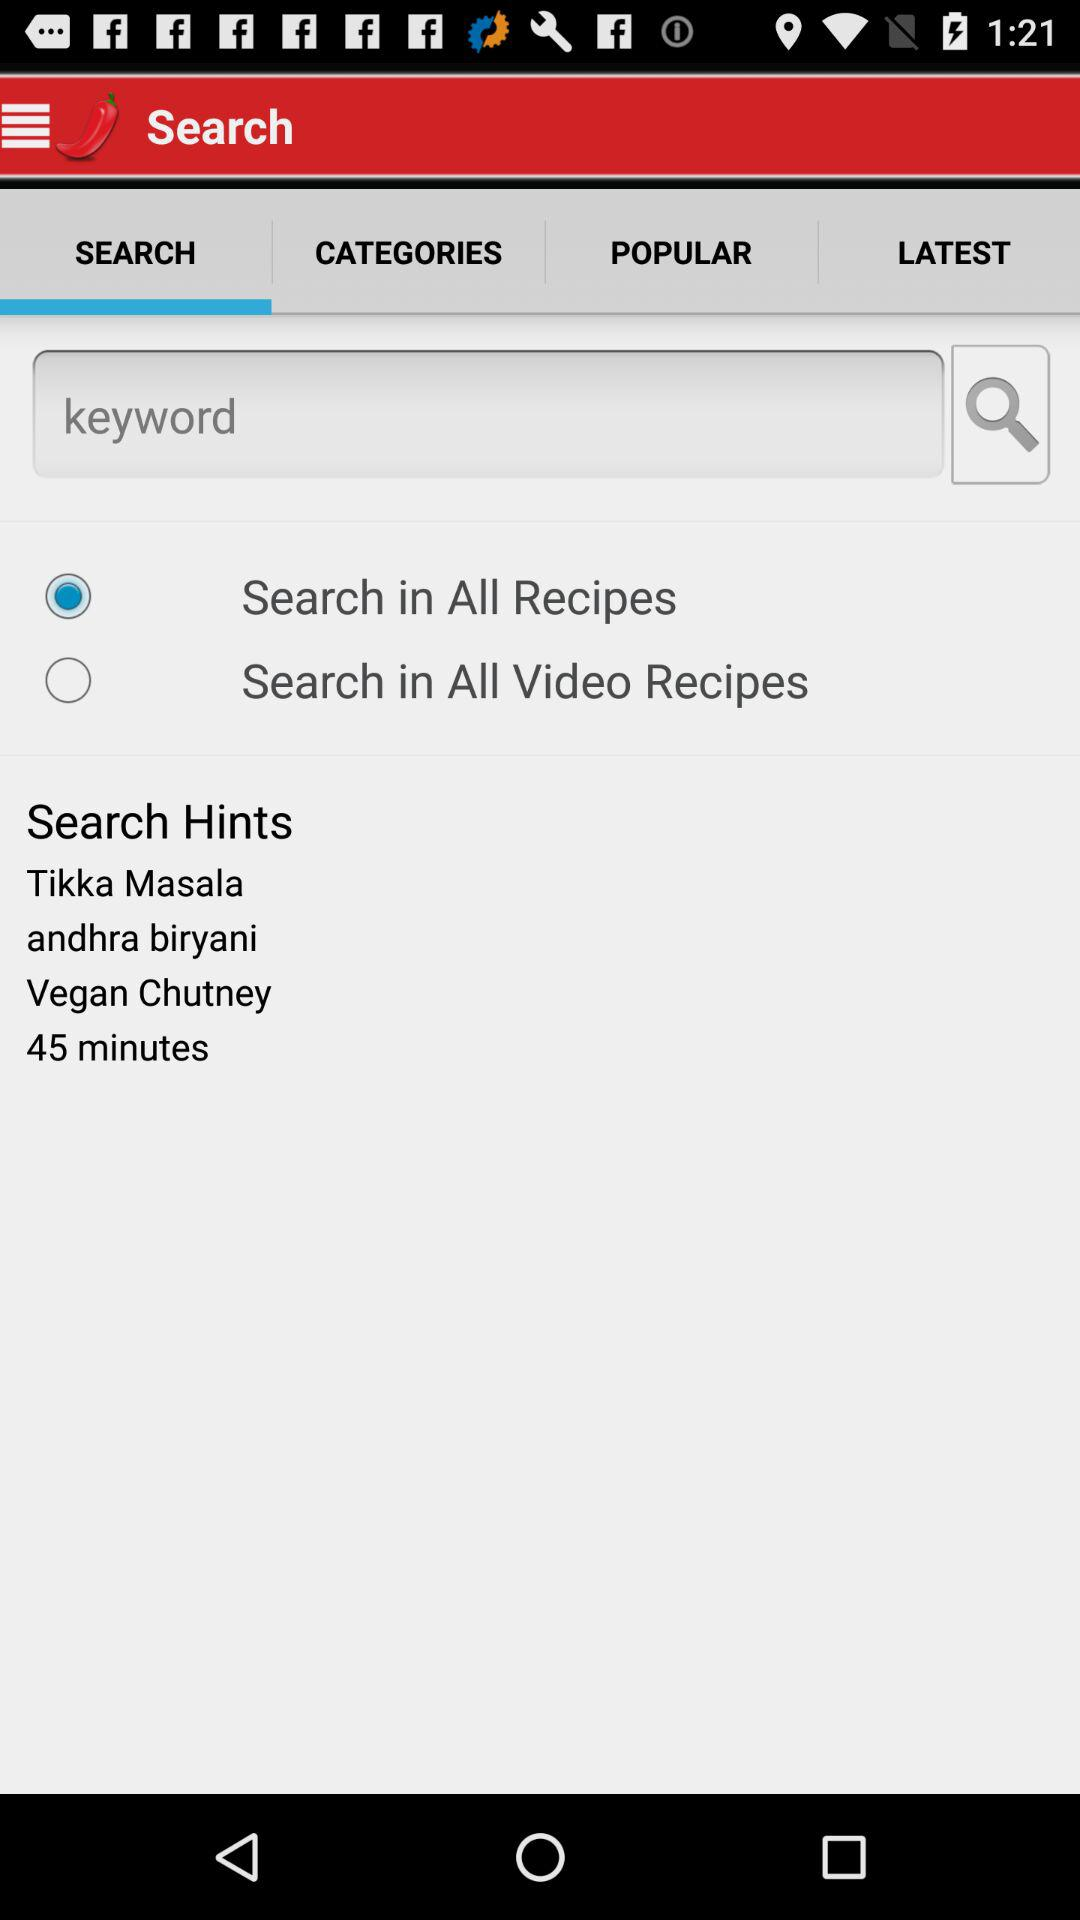Which tab is selected? The selected tab is "SEARCH". 